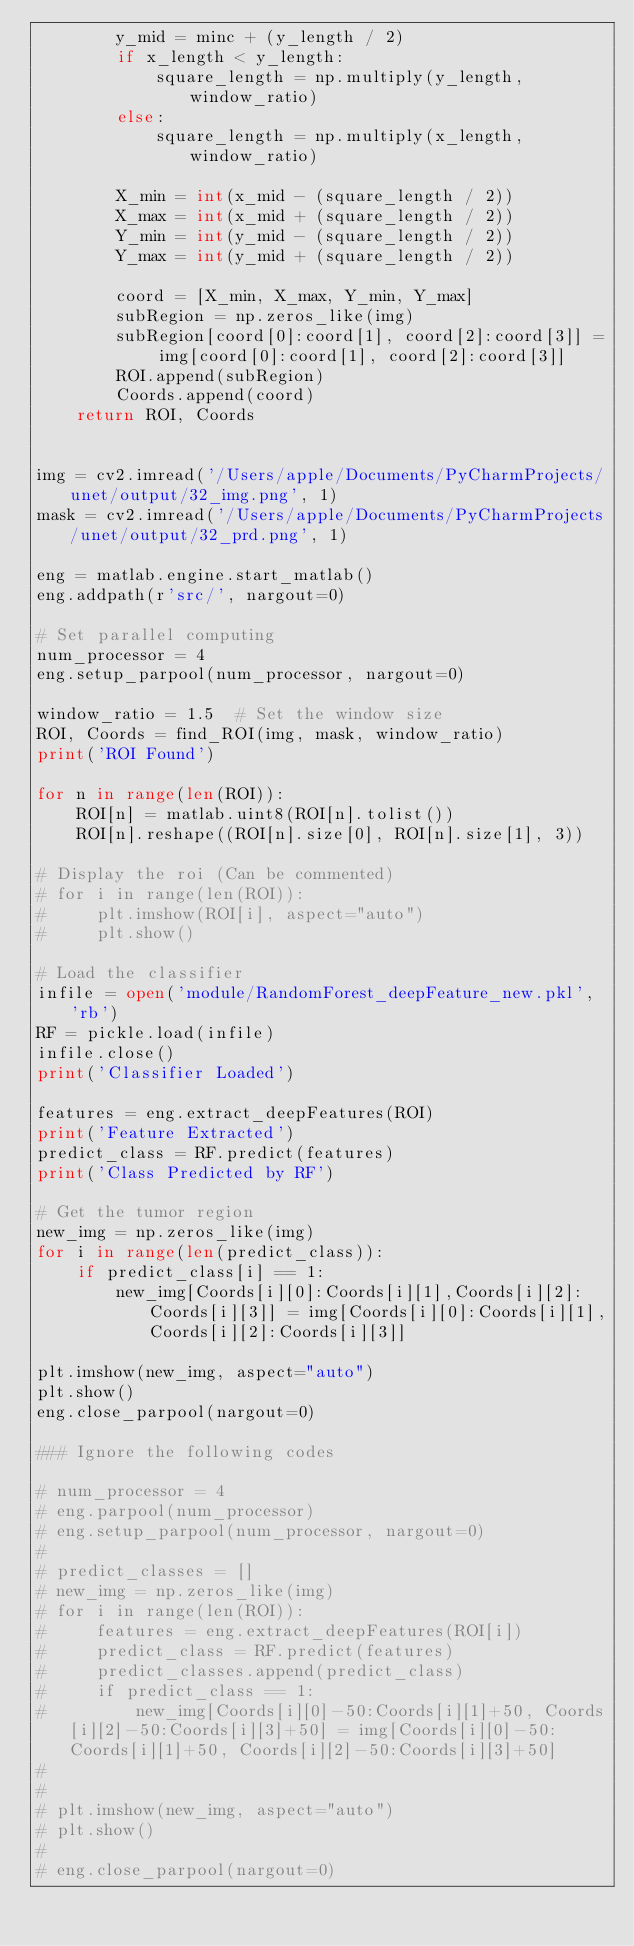Convert code to text. <code><loc_0><loc_0><loc_500><loc_500><_Python_>        y_mid = minc + (y_length / 2)
        if x_length < y_length:
            square_length = np.multiply(y_length, window_ratio)
        else:
            square_length = np.multiply(x_length, window_ratio)

        X_min = int(x_mid - (square_length / 2))
        X_max = int(x_mid + (square_length / 2))
        Y_min = int(y_mid - (square_length / 2))
        Y_max = int(y_mid + (square_length / 2))

        coord = [X_min, X_max, Y_min, Y_max]
        subRegion = np.zeros_like(img)
        subRegion[coord[0]:coord[1], coord[2]:coord[3]] = img[coord[0]:coord[1], coord[2]:coord[3]]
        ROI.append(subRegion)
        Coords.append(coord)
    return ROI, Coords


img = cv2.imread('/Users/apple/Documents/PyCharmProjects/unet/output/32_img.png', 1)
mask = cv2.imread('/Users/apple/Documents/PyCharmProjects/unet/output/32_prd.png', 1)

eng = matlab.engine.start_matlab()
eng.addpath(r'src/', nargout=0)

# Set parallel computing
num_processor = 4
eng.setup_parpool(num_processor, nargout=0)

window_ratio = 1.5  # Set the window size
ROI, Coords = find_ROI(img, mask, window_ratio)
print('ROI Found')

for n in range(len(ROI)):
    ROI[n] = matlab.uint8(ROI[n].tolist())
    ROI[n].reshape((ROI[n].size[0], ROI[n].size[1], 3))

# Display the roi (Can be commented)
# for i in range(len(ROI)):
#     plt.imshow(ROI[i], aspect="auto")
#     plt.show()

# Load the classifier
infile = open('module/RandomForest_deepFeature_new.pkl', 'rb')
RF = pickle.load(infile)
infile.close()
print('Classifier Loaded')

features = eng.extract_deepFeatures(ROI)
print('Feature Extracted')
predict_class = RF.predict(features)
print('Class Predicted by RF')

# Get the tumor region
new_img = np.zeros_like(img)
for i in range(len(predict_class)):
    if predict_class[i] == 1:
        new_img[Coords[i][0]:Coords[i][1],Coords[i][2]:Coords[i][3]] = img[Coords[i][0]:Coords[i][1],Coords[i][2]:Coords[i][3]]

plt.imshow(new_img, aspect="auto")
plt.show()
eng.close_parpool(nargout=0)

### Ignore the following codes

# num_processor = 4
# eng.parpool(num_processor)
# eng.setup_parpool(num_processor, nargout=0)
#
# predict_classes = []
# new_img = np.zeros_like(img)
# for i in range(len(ROI)):
#     features = eng.extract_deepFeatures(ROI[i])
#     predict_class = RF.predict(features)
#     predict_classes.append(predict_class)
#     if predict_class == 1:
#         new_img[Coords[i][0]-50:Coords[i][1]+50, Coords[i][2]-50:Coords[i][3]+50] = img[Coords[i][0]-50:Coords[i][1]+50, Coords[i][2]-50:Coords[i][3]+50]
#
#
# plt.imshow(new_img, aspect="auto")
# plt.show()
#
# eng.close_parpool(nargout=0)













</code> 